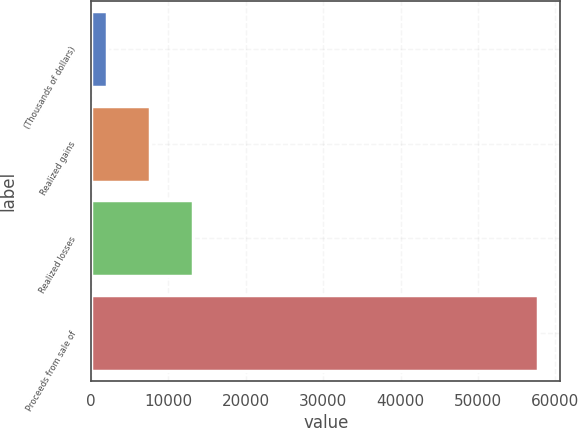<chart> <loc_0><loc_0><loc_500><loc_500><bar_chart><fcel>(Thousands of dollars)<fcel>Realized gains<fcel>Realized losses<fcel>Proceeds from sale of<nl><fcel>2003<fcel>7579.5<fcel>13156<fcel>57768<nl></chart> 